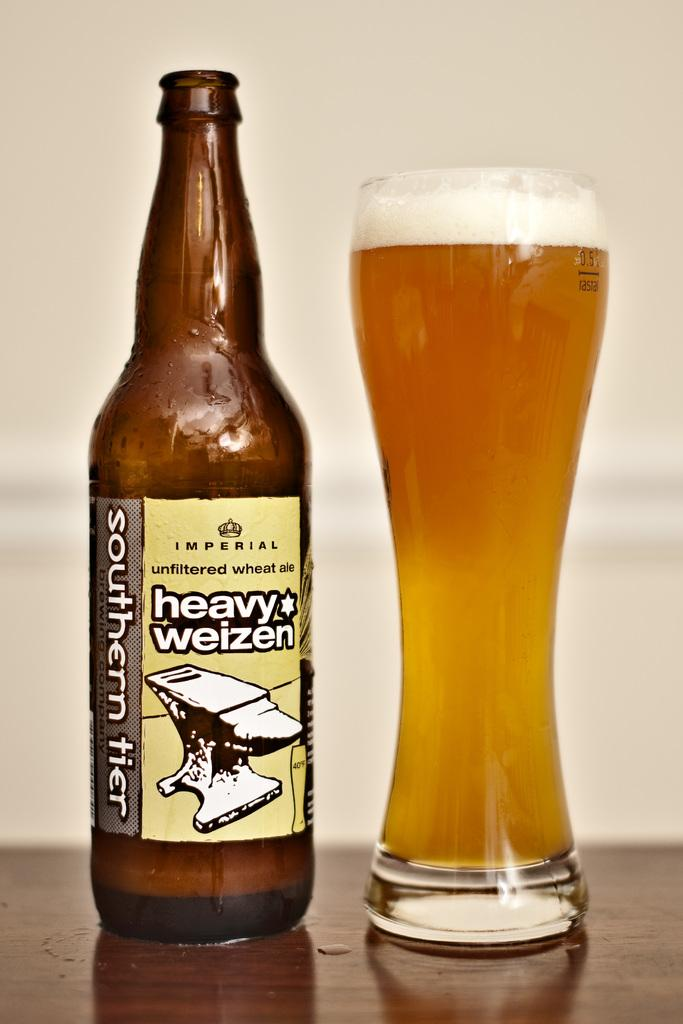Provide a one-sentence caption for the provided image. a bottle of heavy weizen beer site beside a tall glass of beer. 